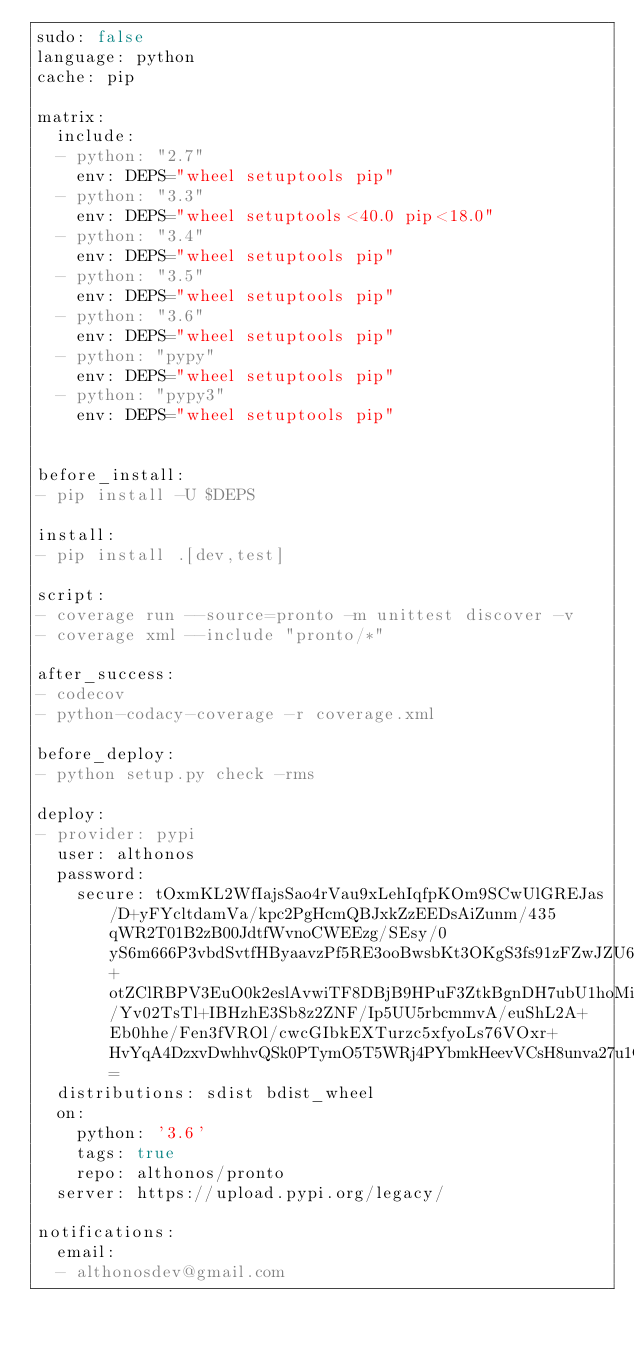Convert code to text. <code><loc_0><loc_0><loc_500><loc_500><_YAML_>sudo: false
language: python
cache: pip

matrix:
  include:
  - python: "2.7"
    env: DEPS="wheel setuptools pip"
  - python: "3.3"
    env: DEPS="wheel setuptools<40.0 pip<18.0"
  - python: "3.4"
    env: DEPS="wheel setuptools pip"
  - python: "3.5"
    env: DEPS="wheel setuptools pip"
  - python: "3.6"
    env: DEPS="wheel setuptools pip"
  - python: "pypy"
    env: DEPS="wheel setuptools pip"
  - python: "pypy3"
    env: DEPS="wheel setuptools pip"


before_install:
- pip install -U $DEPS

install:
- pip install .[dev,test]

script:
- coverage run --source=pronto -m unittest discover -v
- coverage xml --include "pronto/*"

after_success:
- codecov
- python-codacy-coverage -r coverage.xml

before_deploy:
- python setup.py check -rms

deploy:
- provider: pypi
  user: althonos
  password:
    secure: tOxmKL2WfIajsSao4rVau9xLehIqfpKOm9SCwUlGREJas/D+yFYcltdamVa/kpc2PgHcmQBJxkZzEEDsAiZunm/435qWR2T01B2zB00JdtfWvnoCWEEzg/SEsy/0yS6m666P3vbdSvtfHByaavzPf5RE3ooBwsbKt3OKgS3fs91zFZwJZU6zATpBC6pzwhbt6PZeYzmZnk2AkRl8O2abPh8iHz1DGxJ3baY3ObG289W5Dp9a3sr9PVkXvLCMe04JeORTlPt43hnAy6PpnN8FSgKKLdTiMeqRcctZdH8Y90EIW8nWWoqaokNVLepxDDtf3ouy57DNyZu1FNZDlsQd7aYyUrydy7UIrMa33L7ai0hRcvKQI1ymRbO3W4opOPDcORulvYGUNLeVU886lvuLavlJ+otZClRBPV3EuO0k2eslAvwiTF8DBjB9HPuF3ZtkBgnDH7ubU1hoMi6MQvbjVThI0J7uyTVNmnS8r9/Yv02TsTl+IBHzhE3Sb8z2ZNF/Ip5UU5rbcmmvA/euShL2A+Eb0hhe/Fen3fVROl/cwcGIbkEXTurzc5xfyoLs76VOxr+HvYqA4DzxvDwhhvQSk0PTymO5T5WRj4PYbmkHeevVCsH8unva27u1CeKhVYIrWyvXwDhIK11mLzWKT2SAEVypil8YUcQpROR8vJP2yA4=
  distributions: sdist bdist_wheel
  on:
    python: '3.6'
    tags: true
    repo: althonos/pronto
  server: https://upload.pypi.org/legacy/

notifications:
  email:
  - althonosdev@gmail.com
</code> 